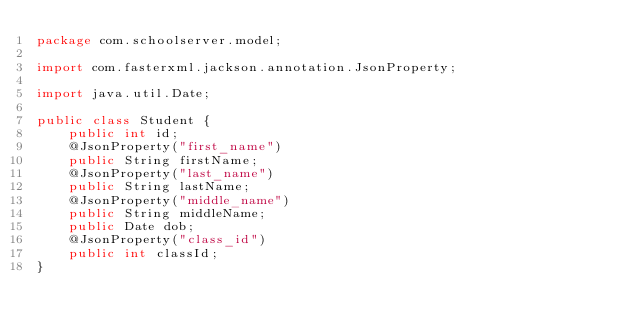<code> <loc_0><loc_0><loc_500><loc_500><_Java_>package com.schoolserver.model;

import com.fasterxml.jackson.annotation.JsonProperty;

import java.util.Date;

public class Student {
    public int id;
    @JsonProperty("first_name")
    public String firstName;
    @JsonProperty("last_name")
    public String lastName;
    @JsonProperty("middle_name")
    public String middleName;
    public Date dob;
    @JsonProperty("class_id")
    public int classId;
}
</code> 